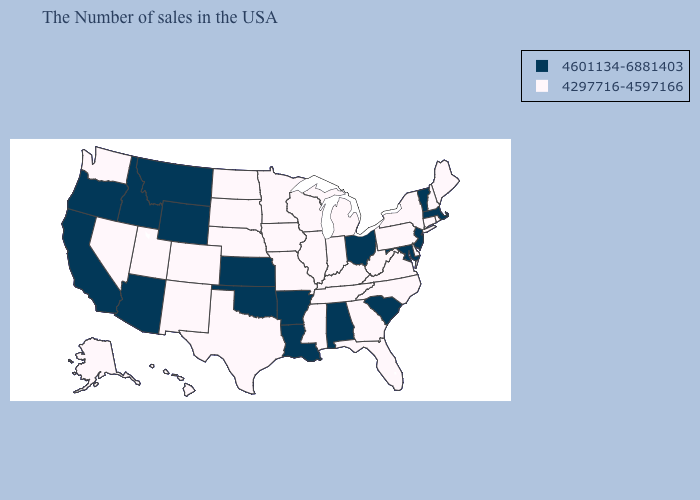Does the first symbol in the legend represent the smallest category?
Short answer required. No. Name the states that have a value in the range 4297716-4597166?
Concise answer only. Maine, Rhode Island, New Hampshire, Connecticut, New York, Delaware, Pennsylvania, Virginia, North Carolina, West Virginia, Florida, Georgia, Michigan, Kentucky, Indiana, Tennessee, Wisconsin, Illinois, Mississippi, Missouri, Minnesota, Iowa, Nebraska, Texas, South Dakota, North Dakota, Colorado, New Mexico, Utah, Nevada, Washington, Alaska, Hawaii. Does the map have missing data?
Give a very brief answer. No. Name the states that have a value in the range 4297716-4597166?
Short answer required. Maine, Rhode Island, New Hampshire, Connecticut, New York, Delaware, Pennsylvania, Virginia, North Carolina, West Virginia, Florida, Georgia, Michigan, Kentucky, Indiana, Tennessee, Wisconsin, Illinois, Mississippi, Missouri, Minnesota, Iowa, Nebraska, Texas, South Dakota, North Dakota, Colorado, New Mexico, Utah, Nevada, Washington, Alaska, Hawaii. Does Michigan have the lowest value in the MidWest?
Give a very brief answer. Yes. What is the value of Georgia?
Answer briefly. 4297716-4597166. What is the value of Utah?
Short answer required. 4297716-4597166. What is the highest value in states that border Illinois?
Answer briefly. 4297716-4597166. Does Ohio have the lowest value in the MidWest?
Quick response, please. No. Is the legend a continuous bar?
Be succinct. No. Does Kansas have the lowest value in the MidWest?
Quick response, please. No. Which states have the lowest value in the Northeast?
Short answer required. Maine, Rhode Island, New Hampshire, Connecticut, New York, Pennsylvania. Name the states that have a value in the range 4601134-6881403?
Short answer required. Massachusetts, Vermont, New Jersey, Maryland, South Carolina, Ohio, Alabama, Louisiana, Arkansas, Kansas, Oklahoma, Wyoming, Montana, Arizona, Idaho, California, Oregon. Among the states that border Nebraska , does Colorado have the lowest value?
Short answer required. Yes. What is the highest value in the South ?
Concise answer only. 4601134-6881403. 